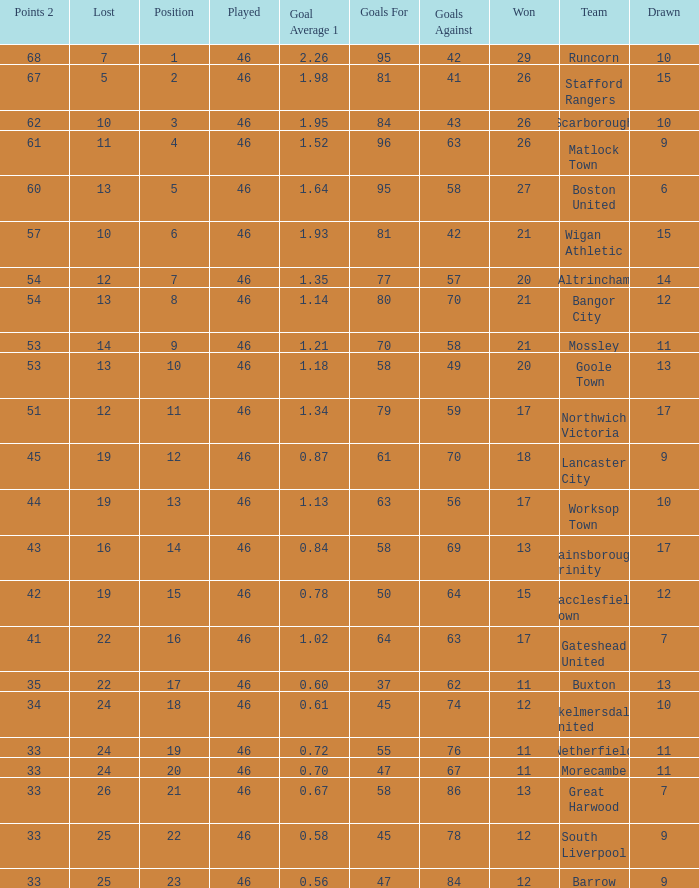List all losses with average goals of 1.21. 14.0. 